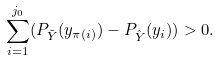<formula> <loc_0><loc_0><loc_500><loc_500>\sum ^ { j _ { 0 } } _ { i = 1 } ( P _ { \tilde { Y } } ( y _ { \pi ( i ) } ) - P _ { \hat { Y } } ( y _ { i } ) ) > 0 .</formula> 